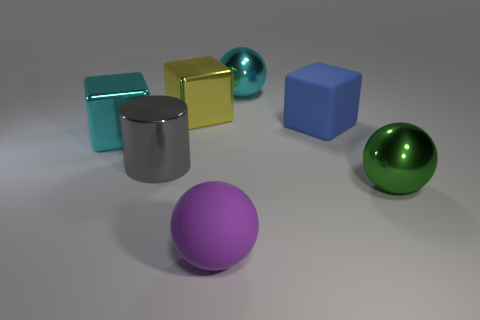Add 2 large purple spheres. How many objects exist? 9 Subtract all cylinders. How many objects are left? 6 Add 2 gray things. How many gray things are left? 3 Add 7 blue rubber blocks. How many blue rubber blocks exist? 8 Subtract 0 red blocks. How many objects are left? 7 Subtract all large objects. Subtract all big yellow matte cylinders. How many objects are left? 0 